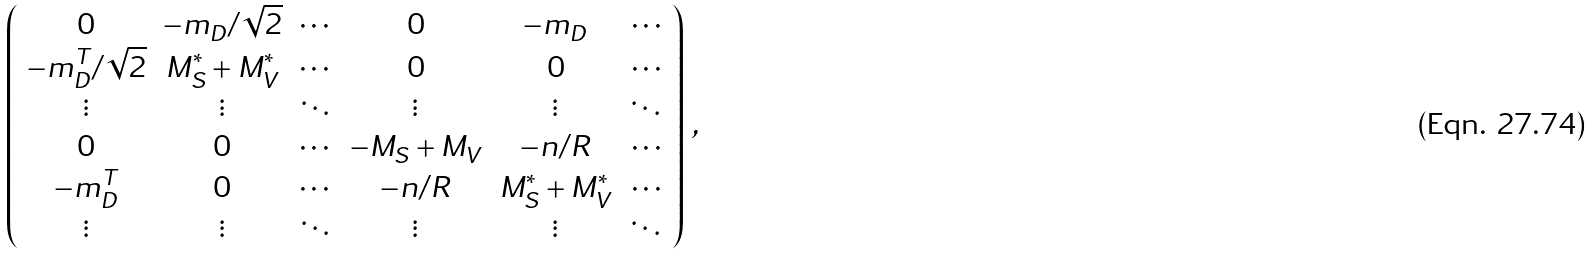Convert formula to latex. <formula><loc_0><loc_0><loc_500><loc_500>\left ( \begin{array} { c c c c c c } 0 & - m _ { D } / \sqrt { 2 } & \cdots & 0 & - m _ { D } & \cdots \\ - m _ { D } ^ { T } / \sqrt { 2 } & M _ { S } ^ { * } + M _ { V } ^ { * } & \cdots & 0 & 0 & \cdots \\ \vdots & \vdots & \ddots & \vdots & \vdots & \ddots \\ 0 & 0 & \cdots & - M _ { S } + M _ { V } & - n / R & \cdots \\ - m _ { D } ^ { T } & 0 & \cdots & - n / R & M _ { S } ^ { * } + M _ { V } ^ { * } & \cdots \\ \vdots & \vdots & \ddots & \vdots & \vdots & \ddots \end{array} \right ) \, ,</formula> 